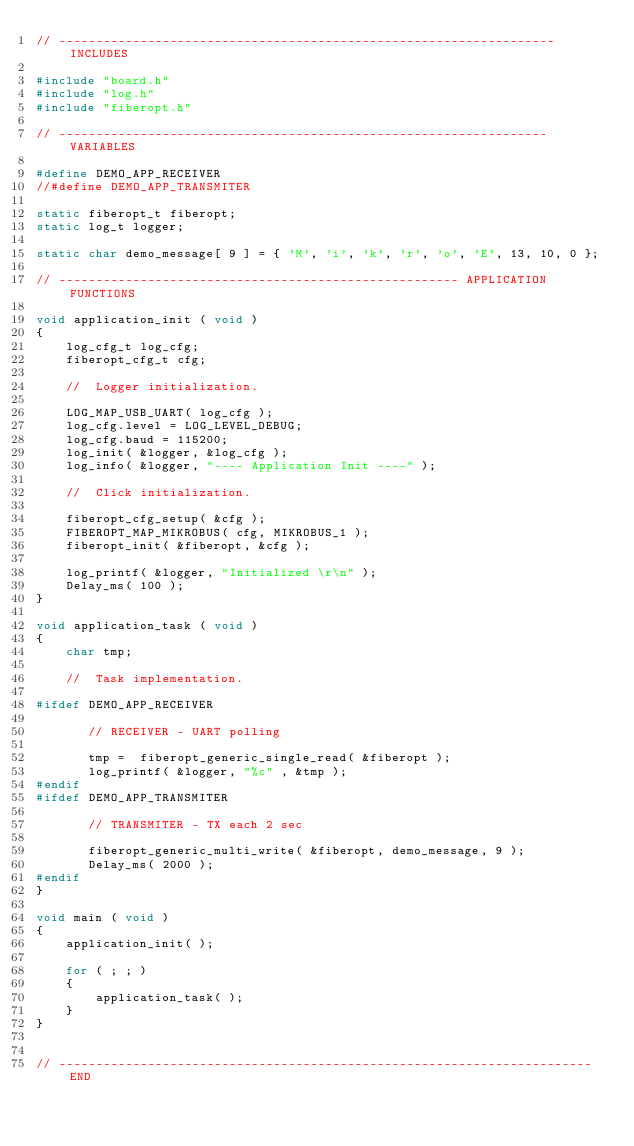Convert code to text. <code><loc_0><loc_0><loc_500><loc_500><_C_>// ------------------------------------------------------------------- INCLUDES

#include "board.h"
#include "log.h"
#include "fiberopt.h"

// ------------------------------------------------------------------ VARIABLES

#define DEMO_APP_RECEIVER
//#define DEMO_APP_TRANSMITER

static fiberopt_t fiberopt;
static log_t logger;

static char demo_message[ 9 ] = { 'M', 'i', 'k', 'r', 'o', 'E', 13, 10, 0 };

// ------------------------------------------------------ APPLICATION FUNCTIONS

void application_init ( void )
{
    log_cfg_t log_cfg;
    fiberopt_cfg_t cfg;

    //  Logger initialization.

    LOG_MAP_USB_UART( log_cfg );
    log_cfg.level = LOG_LEVEL_DEBUG;
    log_cfg.baud = 115200;
    log_init( &logger, &log_cfg );
    log_info( &logger, "---- Application Init ----" );

    //  Click initialization.

    fiberopt_cfg_setup( &cfg );
    FIBEROPT_MAP_MIKROBUS( cfg, MIKROBUS_1 );
    fiberopt_init( &fiberopt, &cfg );

    log_printf( &logger, "Initialized \r\n" );
    Delay_ms( 100 );
}

void application_task ( void )
{
    char tmp;
    
    //  Task implementation.
    
#ifdef DEMO_APP_RECEIVER

       // RECEIVER - UART polling

       tmp =  fiberopt_generic_single_read( &fiberopt );
       log_printf( &logger, "%c" , &tmp );
#endif
#ifdef DEMO_APP_TRANSMITER

       // TRANSMITER - TX each 2 sec
       
       fiberopt_generic_multi_write( &fiberopt, demo_message, 9 );
       Delay_ms( 2000 );
#endif
}

void main ( void )
{
    application_init( );

    for ( ; ; )
    {
        application_task( );
    }
}


// ------------------------------------------------------------------------ END
</code> 